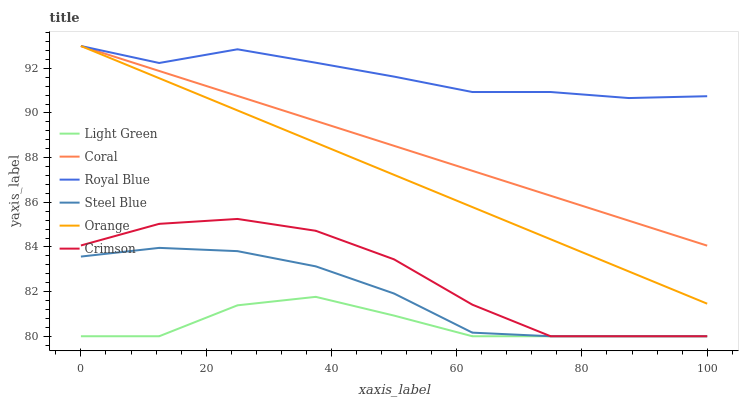Does Light Green have the minimum area under the curve?
Answer yes or no. Yes. Does Royal Blue have the maximum area under the curve?
Answer yes or no. Yes. Does Coral have the minimum area under the curve?
Answer yes or no. No. Does Coral have the maximum area under the curve?
Answer yes or no. No. Is Coral the smoothest?
Answer yes or no. Yes. Is Crimson the roughest?
Answer yes or no. Yes. Is Steel Blue the smoothest?
Answer yes or no. No. Is Steel Blue the roughest?
Answer yes or no. No. Does Light Green have the lowest value?
Answer yes or no. Yes. Does Coral have the lowest value?
Answer yes or no. No. Does Orange have the highest value?
Answer yes or no. Yes. Does Steel Blue have the highest value?
Answer yes or no. No. Is Steel Blue less than Coral?
Answer yes or no. Yes. Is Orange greater than Crimson?
Answer yes or no. Yes. Does Light Green intersect Steel Blue?
Answer yes or no. Yes. Is Light Green less than Steel Blue?
Answer yes or no. No. Is Light Green greater than Steel Blue?
Answer yes or no. No. Does Steel Blue intersect Coral?
Answer yes or no. No. 